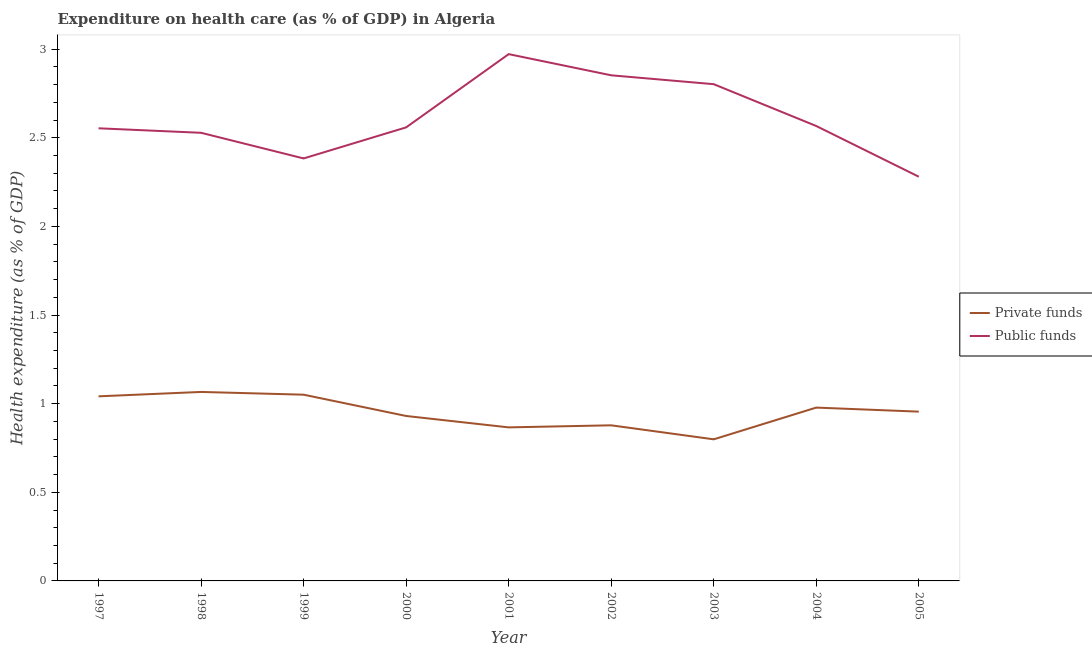Does the line corresponding to amount of private funds spent in healthcare intersect with the line corresponding to amount of public funds spent in healthcare?
Give a very brief answer. No. Is the number of lines equal to the number of legend labels?
Make the answer very short. Yes. What is the amount of private funds spent in healthcare in 2001?
Provide a short and direct response. 0.87. Across all years, what is the maximum amount of private funds spent in healthcare?
Your answer should be compact. 1.07. Across all years, what is the minimum amount of public funds spent in healthcare?
Your answer should be very brief. 2.28. What is the total amount of private funds spent in healthcare in the graph?
Keep it short and to the point. 8.56. What is the difference between the amount of private funds spent in healthcare in 2003 and that in 2005?
Your answer should be very brief. -0.16. What is the difference between the amount of private funds spent in healthcare in 1999 and the amount of public funds spent in healthcare in 2001?
Your response must be concise. -1.92. What is the average amount of public funds spent in healthcare per year?
Keep it short and to the point. 2.61. In the year 2000, what is the difference between the amount of private funds spent in healthcare and amount of public funds spent in healthcare?
Provide a succinct answer. -1.63. In how many years, is the amount of private funds spent in healthcare greater than 1.5 %?
Your response must be concise. 0. What is the ratio of the amount of public funds spent in healthcare in 2002 to that in 2005?
Your answer should be very brief. 1.25. Is the amount of public funds spent in healthcare in 2003 less than that in 2005?
Your response must be concise. No. Is the difference between the amount of private funds spent in healthcare in 2001 and 2003 greater than the difference between the amount of public funds spent in healthcare in 2001 and 2003?
Your response must be concise. No. What is the difference between the highest and the second highest amount of private funds spent in healthcare?
Provide a short and direct response. 0.02. What is the difference between the highest and the lowest amount of private funds spent in healthcare?
Your answer should be very brief. 0.27. Is the sum of the amount of private funds spent in healthcare in 2000 and 2003 greater than the maximum amount of public funds spent in healthcare across all years?
Your answer should be very brief. No. How many lines are there?
Offer a terse response. 2. What is the difference between two consecutive major ticks on the Y-axis?
Your answer should be very brief. 0.5. Does the graph contain any zero values?
Ensure brevity in your answer.  No. Does the graph contain grids?
Keep it short and to the point. No. Where does the legend appear in the graph?
Offer a very short reply. Center right. What is the title of the graph?
Offer a terse response. Expenditure on health care (as % of GDP) in Algeria. What is the label or title of the X-axis?
Provide a short and direct response. Year. What is the label or title of the Y-axis?
Keep it short and to the point. Health expenditure (as % of GDP). What is the Health expenditure (as % of GDP) of Private funds in 1997?
Offer a very short reply. 1.04. What is the Health expenditure (as % of GDP) in Public funds in 1997?
Your answer should be very brief. 2.55. What is the Health expenditure (as % of GDP) in Private funds in 1998?
Make the answer very short. 1.07. What is the Health expenditure (as % of GDP) in Public funds in 1998?
Ensure brevity in your answer.  2.53. What is the Health expenditure (as % of GDP) of Private funds in 1999?
Your answer should be very brief. 1.05. What is the Health expenditure (as % of GDP) in Public funds in 1999?
Provide a succinct answer. 2.38. What is the Health expenditure (as % of GDP) of Private funds in 2000?
Make the answer very short. 0.93. What is the Health expenditure (as % of GDP) of Public funds in 2000?
Offer a very short reply. 2.56. What is the Health expenditure (as % of GDP) of Private funds in 2001?
Your response must be concise. 0.87. What is the Health expenditure (as % of GDP) in Public funds in 2001?
Your answer should be compact. 2.97. What is the Health expenditure (as % of GDP) in Private funds in 2002?
Provide a succinct answer. 0.88. What is the Health expenditure (as % of GDP) in Public funds in 2002?
Give a very brief answer. 2.85. What is the Health expenditure (as % of GDP) of Private funds in 2003?
Offer a terse response. 0.8. What is the Health expenditure (as % of GDP) of Public funds in 2003?
Offer a terse response. 2.8. What is the Health expenditure (as % of GDP) in Private funds in 2004?
Your answer should be very brief. 0.98. What is the Health expenditure (as % of GDP) in Public funds in 2004?
Your answer should be compact. 2.57. What is the Health expenditure (as % of GDP) of Private funds in 2005?
Provide a succinct answer. 0.95. What is the Health expenditure (as % of GDP) in Public funds in 2005?
Keep it short and to the point. 2.28. Across all years, what is the maximum Health expenditure (as % of GDP) of Private funds?
Make the answer very short. 1.07. Across all years, what is the maximum Health expenditure (as % of GDP) of Public funds?
Offer a very short reply. 2.97. Across all years, what is the minimum Health expenditure (as % of GDP) in Private funds?
Provide a succinct answer. 0.8. Across all years, what is the minimum Health expenditure (as % of GDP) in Public funds?
Offer a terse response. 2.28. What is the total Health expenditure (as % of GDP) of Private funds in the graph?
Provide a succinct answer. 8.56. What is the total Health expenditure (as % of GDP) in Public funds in the graph?
Ensure brevity in your answer.  23.5. What is the difference between the Health expenditure (as % of GDP) of Private funds in 1997 and that in 1998?
Offer a terse response. -0.02. What is the difference between the Health expenditure (as % of GDP) in Public funds in 1997 and that in 1998?
Keep it short and to the point. 0.03. What is the difference between the Health expenditure (as % of GDP) in Private funds in 1997 and that in 1999?
Your response must be concise. -0.01. What is the difference between the Health expenditure (as % of GDP) in Public funds in 1997 and that in 1999?
Offer a terse response. 0.17. What is the difference between the Health expenditure (as % of GDP) of Private funds in 1997 and that in 2000?
Ensure brevity in your answer.  0.11. What is the difference between the Health expenditure (as % of GDP) of Public funds in 1997 and that in 2000?
Your response must be concise. -0.01. What is the difference between the Health expenditure (as % of GDP) in Private funds in 1997 and that in 2001?
Ensure brevity in your answer.  0.18. What is the difference between the Health expenditure (as % of GDP) of Public funds in 1997 and that in 2001?
Make the answer very short. -0.42. What is the difference between the Health expenditure (as % of GDP) in Private funds in 1997 and that in 2002?
Offer a very short reply. 0.16. What is the difference between the Health expenditure (as % of GDP) in Public funds in 1997 and that in 2002?
Ensure brevity in your answer.  -0.3. What is the difference between the Health expenditure (as % of GDP) in Private funds in 1997 and that in 2003?
Offer a terse response. 0.24. What is the difference between the Health expenditure (as % of GDP) in Public funds in 1997 and that in 2003?
Your answer should be very brief. -0.25. What is the difference between the Health expenditure (as % of GDP) in Private funds in 1997 and that in 2004?
Ensure brevity in your answer.  0.06. What is the difference between the Health expenditure (as % of GDP) in Public funds in 1997 and that in 2004?
Make the answer very short. -0.01. What is the difference between the Health expenditure (as % of GDP) of Private funds in 1997 and that in 2005?
Your answer should be compact. 0.09. What is the difference between the Health expenditure (as % of GDP) in Public funds in 1997 and that in 2005?
Offer a very short reply. 0.27. What is the difference between the Health expenditure (as % of GDP) in Private funds in 1998 and that in 1999?
Offer a terse response. 0.02. What is the difference between the Health expenditure (as % of GDP) of Public funds in 1998 and that in 1999?
Offer a very short reply. 0.14. What is the difference between the Health expenditure (as % of GDP) in Private funds in 1998 and that in 2000?
Keep it short and to the point. 0.14. What is the difference between the Health expenditure (as % of GDP) in Public funds in 1998 and that in 2000?
Your answer should be very brief. -0.03. What is the difference between the Health expenditure (as % of GDP) in Private funds in 1998 and that in 2001?
Your response must be concise. 0.2. What is the difference between the Health expenditure (as % of GDP) in Public funds in 1998 and that in 2001?
Your answer should be compact. -0.44. What is the difference between the Health expenditure (as % of GDP) in Private funds in 1998 and that in 2002?
Your response must be concise. 0.19. What is the difference between the Health expenditure (as % of GDP) in Public funds in 1998 and that in 2002?
Your answer should be very brief. -0.32. What is the difference between the Health expenditure (as % of GDP) in Private funds in 1998 and that in 2003?
Your response must be concise. 0.27. What is the difference between the Health expenditure (as % of GDP) in Public funds in 1998 and that in 2003?
Offer a terse response. -0.27. What is the difference between the Health expenditure (as % of GDP) of Private funds in 1998 and that in 2004?
Make the answer very short. 0.09. What is the difference between the Health expenditure (as % of GDP) of Public funds in 1998 and that in 2004?
Your response must be concise. -0.04. What is the difference between the Health expenditure (as % of GDP) of Private funds in 1998 and that in 2005?
Provide a succinct answer. 0.11. What is the difference between the Health expenditure (as % of GDP) in Public funds in 1998 and that in 2005?
Offer a very short reply. 0.25. What is the difference between the Health expenditure (as % of GDP) in Private funds in 1999 and that in 2000?
Your answer should be very brief. 0.12. What is the difference between the Health expenditure (as % of GDP) of Public funds in 1999 and that in 2000?
Provide a short and direct response. -0.18. What is the difference between the Health expenditure (as % of GDP) in Private funds in 1999 and that in 2001?
Offer a terse response. 0.18. What is the difference between the Health expenditure (as % of GDP) of Public funds in 1999 and that in 2001?
Your answer should be very brief. -0.59. What is the difference between the Health expenditure (as % of GDP) of Private funds in 1999 and that in 2002?
Give a very brief answer. 0.17. What is the difference between the Health expenditure (as % of GDP) of Public funds in 1999 and that in 2002?
Offer a terse response. -0.47. What is the difference between the Health expenditure (as % of GDP) in Private funds in 1999 and that in 2003?
Your answer should be compact. 0.25. What is the difference between the Health expenditure (as % of GDP) of Public funds in 1999 and that in 2003?
Make the answer very short. -0.42. What is the difference between the Health expenditure (as % of GDP) of Private funds in 1999 and that in 2004?
Provide a short and direct response. 0.07. What is the difference between the Health expenditure (as % of GDP) in Public funds in 1999 and that in 2004?
Make the answer very short. -0.18. What is the difference between the Health expenditure (as % of GDP) of Private funds in 1999 and that in 2005?
Give a very brief answer. 0.1. What is the difference between the Health expenditure (as % of GDP) in Public funds in 1999 and that in 2005?
Keep it short and to the point. 0.1. What is the difference between the Health expenditure (as % of GDP) of Private funds in 2000 and that in 2001?
Offer a terse response. 0.06. What is the difference between the Health expenditure (as % of GDP) of Public funds in 2000 and that in 2001?
Make the answer very short. -0.41. What is the difference between the Health expenditure (as % of GDP) of Private funds in 2000 and that in 2002?
Give a very brief answer. 0.05. What is the difference between the Health expenditure (as % of GDP) of Public funds in 2000 and that in 2002?
Your answer should be very brief. -0.29. What is the difference between the Health expenditure (as % of GDP) of Private funds in 2000 and that in 2003?
Give a very brief answer. 0.13. What is the difference between the Health expenditure (as % of GDP) in Public funds in 2000 and that in 2003?
Make the answer very short. -0.24. What is the difference between the Health expenditure (as % of GDP) in Private funds in 2000 and that in 2004?
Offer a terse response. -0.05. What is the difference between the Health expenditure (as % of GDP) in Public funds in 2000 and that in 2004?
Your response must be concise. -0.01. What is the difference between the Health expenditure (as % of GDP) in Private funds in 2000 and that in 2005?
Provide a succinct answer. -0.02. What is the difference between the Health expenditure (as % of GDP) in Public funds in 2000 and that in 2005?
Ensure brevity in your answer.  0.28. What is the difference between the Health expenditure (as % of GDP) in Private funds in 2001 and that in 2002?
Offer a very short reply. -0.01. What is the difference between the Health expenditure (as % of GDP) in Public funds in 2001 and that in 2002?
Make the answer very short. 0.12. What is the difference between the Health expenditure (as % of GDP) of Private funds in 2001 and that in 2003?
Offer a very short reply. 0.07. What is the difference between the Health expenditure (as % of GDP) in Public funds in 2001 and that in 2003?
Ensure brevity in your answer.  0.17. What is the difference between the Health expenditure (as % of GDP) in Private funds in 2001 and that in 2004?
Ensure brevity in your answer.  -0.11. What is the difference between the Health expenditure (as % of GDP) of Public funds in 2001 and that in 2004?
Keep it short and to the point. 0.41. What is the difference between the Health expenditure (as % of GDP) of Private funds in 2001 and that in 2005?
Your answer should be very brief. -0.09. What is the difference between the Health expenditure (as % of GDP) of Public funds in 2001 and that in 2005?
Keep it short and to the point. 0.69. What is the difference between the Health expenditure (as % of GDP) of Private funds in 2002 and that in 2003?
Provide a short and direct response. 0.08. What is the difference between the Health expenditure (as % of GDP) in Public funds in 2002 and that in 2004?
Give a very brief answer. 0.29. What is the difference between the Health expenditure (as % of GDP) in Private funds in 2002 and that in 2005?
Provide a short and direct response. -0.08. What is the difference between the Health expenditure (as % of GDP) in Public funds in 2002 and that in 2005?
Your answer should be compact. 0.57. What is the difference between the Health expenditure (as % of GDP) of Private funds in 2003 and that in 2004?
Ensure brevity in your answer.  -0.18. What is the difference between the Health expenditure (as % of GDP) of Public funds in 2003 and that in 2004?
Your response must be concise. 0.24. What is the difference between the Health expenditure (as % of GDP) in Private funds in 2003 and that in 2005?
Keep it short and to the point. -0.16. What is the difference between the Health expenditure (as % of GDP) of Public funds in 2003 and that in 2005?
Offer a terse response. 0.52. What is the difference between the Health expenditure (as % of GDP) of Private funds in 2004 and that in 2005?
Offer a very short reply. 0.02. What is the difference between the Health expenditure (as % of GDP) in Public funds in 2004 and that in 2005?
Your response must be concise. 0.29. What is the difference between the Health expenditure (as % of GDP) in Private funds in 1997 and the Health expenditure (as % of GDP) in Public funds in 1998?
Your answer should be very brief. -1.49. What is the difference between the Health expenditure (as % of GDP) in Private funds in 1997 and the Health expenditure (as % of GDP) in Public funds in 1999?
Your answer should be compact. -1.34. What is the difference between the Health expenditure (as % of GDP) of Private funds in 1997 and the Health expenditure (as % of GDP) of Public funds in 2000?
Ensure brevity in your answer.  -1.52. What is the difference between the Health expenditure (as % of GDP) of Private funds in 1997 and the Health expenditure (as % of GDP) of Public funds in 2001?
Keep it short and to the point. -1.93. What is the difference between the Health expenditure (as % of GDP) of Private funds in 1997 and the Health expenditure (as % of GDP) of Public funds in 2002?
Provide a succinct answer. -1.81. What is the difference between the Health expenditure (as % of GDP) in Private funds in 1997 and the Health expenditure (as % of GDP) in Public funds in 2003?
Provide a succinct answer. -1.76. What is the difference between the Health expenditure (as % of GDP) of Private funds in 1997 and the Health expenditure (as % of GDP) of Public funds in 2004?
Keep it short and to the point. -1.52. What is the difference between the Health expenditure (as % of GDP) of Private funds in 1997 and the Health expenditure (as % of GDP) of Public funds in 2005?
Your response must be concise. -1.24. What is the difference between the Health expenditure (as % of GDP) of Private funds in 1998 and the Health expenditure (as % of GDP) of Public funds in 1999?
Your answer should be compact. -1.32. What is the difference between the Health expenditure (as % of GDP) in Private funds in 1998 and the Health expenditure (as % of GDP) in Public funds in 2000?
Make the answer very short. -1.49. What is the difference between the Health expenditure (as % of GDP) of Private funds in 1998 and the Health expenditure (as % of GDP) of Public funds in 2001?
Ensure brevity in your answer.  -1.91. What is the difference between the Health expenditure (as % of GDP) of Private funds in 1998 and the Health expenditure (as % of GDP) of Public funds in 2002?
Keep it short and to the point. -1.79. What is the difference between the Health expenditure (as % of GDP) in Private funds in 1998 and the Health expenditure (as % of GDP) in Public funds in 2003?
Your answer should be very brief. -1.74. What is the difference between the Health expenditure (as % of GDP) in Private funds in 1998 and the Health expenditure (as % of GDP) in Public funds in 2004?
Make the answer very short. -1.5. What is the difference between the Health expenditure (as % of GDP) of Private funds in 1998 and the Health expenditure (as % of GDP) of Public funds in 2005?
Provide a succinct answer. -1.21. What is the difference between the Health expenditure (as % of GDP) of Private funds in 1999 and the Health expenditure (as % of GDP) of Public funds in 2000?
Your answer should be compact. -1.51. What is the difference between the Health expenditure (as % of GDP) of Private funds in 1999 and the Health expenditure (as % of GDP) of Public funds in 2001?
Keep it short and to the point. -1.92. What is the difference between the Health expenditure (as % of GDP) of Private funds in 1999 and the Health expenditure (as % of GDP) of Public funds in 2002?
Offer a very short reply. -1.8. What is the difference between the Health expenditure (as % of GDP) of Private funds in 1999 and the Health expenditure (as % of GDP) of Public funds in 2003?
Keep it short and to the point. -1.75. What is the difference between the Health expenditure (as % of GDP) in Private funds in 1999 and the Health expenditure (as % of GDP) in Public funds in 2004?
Keep it short and to the point. -1.52. What is the difference between the Health expenditure (as % of GDP) in Private funds in 1999 and the Health expenditure (as % of GDP) in Public funds in 2005?
Your response must be concise. -1.23. What is the difference between the Health expenditure (as % of GDP) in Private funds in 2000 and the Health expenditure (as % of GDP) in Public funds in 2001?
Make the answer very short. -2.04. What is the difference between the Health expenditure (as % of GDP) of Private funds in 2000 and the Health expenditure (as % of GDP) of Public funds in 2002?
Give a very brief answer. -1.92. What is the difference between the Health expenditure (as % of GDP) of Private funds in 2000 and the Health expenditure (as % of GDP) of Public funds in 2003?
Your response must be concise. -1.87. What is the difference between the Health expenditure (as % of GDP) in Private funds in 2000 and the Health expenditure (as % of GDP) in Public funds in 2004?
Offer a terse response. -1.64. What is the difference between the Health expenditure (as % of GDP) of Private funds in 2000 and the Health expenditure (as % of GDP) of Public funds in 2005?
Offer a very short reply. -1.35. What is the difference between the Health expenditure (as % of GDP) of Private funds in 2001 and the Health expenditure (as % of GDP) of Public funds in 2002?
Ensure brevity in your answer.  -1.99. What is the difference between the Health expenditure (as % of GDP) of Private funds in 2001 and the Health expenditure (as % of GDP) of Public funds in 2003?
Your answer should be very brief. -1.94. What is the difference between the Health expenditure (as % of GDP) in Private funds in 2001 and the Health expenditure (as % of GDP) in Public funds in 2004?
Offer a terse response. -1.7. What is the difference between the Health expenditure (as % of GDP) in Private funds in 2001 and the Health expenditure (as % of GDP) in Public funds in 2005?
Your answer should be compact. -1.41. What is the difference between the Health expenditure (as % of GDP) in Private funds in 2002 and the Health expenditure (as % of GDP) in Public funds in 2003?
Your answer should be very brief. -1.92. What is the difference between the Health expenditure (as % of GDP) in Private funds in 2002 and the Health expenditure (as % of GDP) in Public funds in 2004?
Give a very brief answer. -1.69. What is the difference between the Health expenditure (as % of GDP) in Private funds in 2002 and the Health expenditure (as % of GDP) in Public funds in 2005?
Keep it short and to the point. -1.4. What is the difference between the Health expenditure (as % of GDP) in Private funds in 2003 and the Health expenditure (as % of GDP) in Public funds in 2004?
Your answer should be compact. -1.77. What is the difference between the Health expenditure (as % of GDP) of Private funds in 2003 and the Health expenditure (as % of GDP) of Public funds in 2005?
Ensure brevity in your answer.  -1.48. What is the difference between the Health expenditure (as % of GDP) in Private funds in 2004 and the Health expenditure (as % of GDP) in Public funds in 2005?
Ensure brevity in your answer.  -1.3. What is the average Health expenditure (as % of GDP) in Private funds per year?
Provide a short and direct response. 0.95. What is the average Health expenditure (as % of GDP) of Public funds per year?
Your response must be concise. 2.61. In the year 1997, what is the difference between the Health expenditure (as % of GDP) in Private funds and Health expenditure (as % of GDP) in Public funds?
Provide a short and direct response. -1.51. In the year 1998, what is the difference between the Health expenditure (as % of GDP) in Private funds and Health expenditure (as % of GDP) in Public funds?
Ensure brevity in your answer.  -1.46. In the year 1999, what is the difference between the Health expenditure (as % of GDP) of Private funds and Health expenditure (as % of GDP) of Public funds?
Provide a short and direct response. -1.33. In the year 2000, what is the difference between the Health expenditure (as % of GDP) in Private funds and Health expenditure (as % of GDP) in Public funds?
Make the answer very short. -1.63. In the year 2001, what is the difference between the Health expenditure (as % of GDP) in Private funds and Health expenditure (as % of GDP) in Public funds?
Offer a very short reply. -2.11. In the year 2002, what is the difference between the Health expenditure (as % of GDP) of Private funds and Health expenditure (as % of GDP) of Public funds?
Give a very brief answer. -1.97. In the year 2003, what is the difference between the Health expenditure (as % of GDP) in Private funds and Health expenditure (as % of GDP) in Public funds?
Offer a terse response. -2. In the year 2004, what is the difference between the Health expenditure (as % of GDP) of Private funds and Health expenditure (as % of GDP) of Public funds?
Your answer should be very brief. -1.59. In the year 2005, what is the difference between the Health expenditure (as % of GDP) of Private funds and Health expenditure (as % of GDP) of Public funds?
Your answer should be very brief. -1.33. What is the ratio of the Health expenditure (as % of GDP) of Private funds in 1997 to that in 1998?
Make the answer very short. 0.98. What is the ratio of the Health expenditure (as % of GDP) in Public funds in 1997 to that in 1999?
Provide a succinct answer. 1.07. What is the ratio of the Health expenditure (as % of GDP) in Private funds in 1997 to that in 2000?
Make the answer very short. 1.12. What is the ratio of the Health expenditure (as % of GDP) in Public funds in 1997 to that in 2000?
Your answer should be compact. 1. What is the ratio of the Health expenditure (as % of GDP) of Private funds in 1997 to that in 2001?
Provide a succinct answer. 1.2. What is the ratio of the Health expenditure (as % of GDP) of Public funds in 1997 to that in 2001?
Provide a succinct answer. 0.86. What is the ratio of the Health expenditure (as % of GDP) in Private funds in 1997 to that in 2002?
Your answer should be compact. 1.19. What is the ratio of the Health expenditure (as % of GDP) of Public funds in 1997 to that in 2002?
Offer a very short reply. 0.9. What is the ratio of the Health expenditure (as % of GDP) of Private funds in 1997 to that in 2003?
Offer a very short reply. 1.3. What is the ratio of the Health expenditure (as % of GDP) of Public funds in 1997 to that in 2003?
Offer a very short reply. 0.91. What is the ratio of the Health expenditure (as % of GDP) of Private funds in 1997 to that in 2004?
Make the answer very short. 1.06. What is the ratio of the Health expenditure (as % of GDP) in Private funds in 1997 to that in 2005?
Your answer should be compact. 1.09. What is the ratio of the Health expenditure (as % of GDP) of Public funds in 1997 to that in 2005?
Give a very brief answer. 1.12. What is the ratio of the Health expenditure (as % of GDP) of Private funds in 1998 to that in 1999?
Ensure brevity in your answer.  1.01. What is the ratio of the Health expenditure (as % of GDP) of Public funds in 1998 to that in 1999?
Keep it short and to the point. 1.06. What is the ratio of the Health expenditure (as % of GDP) in Private funds in 1998 to that in 2000?
Give a very brief answer. 1.15. What is the ratio of the Health expenditure (as % of GDP) of Private funds in 1998 to that in 2001?
Your response must be concise. 1.23. What is the ratio of the Health expenditure (as % of GDP) of Public funds in 1998 to that in 2001?
Ensure brevity in your answer.  0.85. What is the ratio of the Health expenditure (as % of GDP) in Private funds in 1998 to that in 2002?
Offer a very short reply. 1.21. What is the ratio of the Health expenditure (as % of GDP) in Public funds in 1998 to that in 2002?
Provide a succinct answer. 0.89. What is the ratio of the Health expenditure (as % of GDP) in Private funds in 1998 to that in 2003?
Keep it short and to the point. 1.33. What is the ratio of the Health expenditure (as % of GDP) of Public funds in 1998 to that in 2003?
Your response must be concise. 0.9. What is the ratio of the Health expenditure (as % of GDP) of Private funds in 1998 to that in 2004?
Offer a very short reply. 1.09. What is the ratio of the Health expenditure (as % of GDP) in Public funds in 1998 to that in 2004?
Give a very brief answer. 0.99. What is the ratio of the Health expenditure (as % of GDP) of Private funds in 1998 to that in 2005?
Provide a short and direct response. 1.12. What is the ratio of the Health expenditure (as % of GDP) of Public funds in 1998 to that in 2005?
Make the answer very short. 1.11. What is the ratio of the Health expenditure (as % of GDP) of Private funds in 1999 to that in 2000?
Your answer should be compact. 1.13. What is the ratio of the Health expenditure (as % of GDP) of Public funds in 1999 to that in 2000?
Give a very brief answer. 0.93. What is the ratio of the Health expenditure (as % of GDP) in Private funds in 1999 to that in 2001?
Your answer should be compact. 1.21. What is the ratio of the Health expenditure (as % of GDP) of Public funds in 1999 to that in 2001?
Give a very brief answer. 0.8. What is the ratio of the Health expenditure (as % of GDP) of Private funds in 1999 to that in 2002?
Your answer should be very brief. 1.2. What is the ratio of the Health expenditure (as % of GDP) of Public funds in 1999 to that in 2002?
Ensure brevity in your answer.  0.84. What is the ratio of the Health expenditure (as % of GDP) in Private funds in 1999 to that in 2003?
Your answer should be very brief. 1.32. What is the ratio of the Health expenditure (as % of GDP) in Public funds in 1999 to that in 2003?
Your response must be concise. 0.85. What is the ratio of the Health expenditure (as % of GDP) in Private funds in 1999 to that in 2004?
Ensure brevity in your answer.  1.07. What is the ratio of the Health expenditure (as % of GDP) in Public funds in 1999 to that in 2004?
Provide a short and direct response. 0.93. What is the ratio of the Health expenditure (as % of GDP) of Private funds in 1999 to that in 2005?
Make the answer very short. 1.1. What is the ratio of the Health expenditure (as % of GDP) of Public funds in 1999 to that in 2005?
Offer a very short reply. 1.05. What is the ratio of the Health expenditure (as % of GDP) of Private funds in 2000 to that in 2001?
Offer a terse response. 1.07. What is the ratio of the Health expenditure (as % of GDP) of Public funds in 2000 to that in 2001?
Ensure brevity in your answer.  0.86. What is the ratio of the Health expenditure (as % of GDP) in Private funds in 2000 to that in 2002?
Provide a succinct answer. 1.06. What is the ratio of the Health expenditure (as % of GDP) in Public funds in 2000 to that in 2002?
Make the answer very short. 0.9. What is the ratio of the Health expenditure (as % of GDP) of Private funds in 2000 to that in 2003?
Provide a short and direct response. 1.16. What is the ratio of the Health expenditure (as % of GDP) of Public funds in 2000 to that in 2003?
Provide a short and direct response. 0.91. What is the ratio of the Health expenditure (as % of GDP) in Private funds in 2000 to that in 2004?
Provide a succinct answer. 0.95. What is the ratio of the Health expenditure (as % of GDP) of Private funds in 2000 to that in 2005?
Keep it short and to the point. 0.97. What is the ratio of the Health expenditure (as % of GDP) of Public funds in 2000 to that in 2005?
Your response must be concise. 1.12. What is the ratio of the Health expenditure (as % of GDP) of Private funds in 2001 to that in 2002?
Your response must be concise. 0.99. What is the ratio of the Health expenditure (as % of GDP) of Public funds in 2001 to that in 2002?
Give a very brief answer. 1.04. What is the ratio of the Health expenditure (as % of GDP) of Private funds in 2001 to that in 2003?
Your answer should be compact. 1.08. What is the ratio of the Health expenditure (as % of GDP) in Public funds in 2001 to that in 2003?
Ensure brevity in your answer.  1.06. What is the ratio of the Health expenditure (as % of GDP) in Private funds in 2001 to that in 2004?
Offer a terse response. 0.89. What is the ratio of the Health expenditure (as % of GDP) of Public funds in 2001 to that in 2004?
Provide a short and direct response. 1.16. What is the ratio of the Health expenditure (as % of GDP) of Private funds in 2001 to that in 2005?
Keep it short and to the point. 0.91. What is the ratio of the Health expenditure (as % of GDP) in Public funds in 2001 to that in 2005?
Your answer should be compact. 1.3. What is the ratio of the Health expenditure (as % of GDP) of Private funds in 2002 to that in 2003?
Keep it short and to the point. 1.1. What is the ratio of the Health expenditure (as % of GDP) of Public funds in 2002 to that in 2003?
Your response must be concise. 1.02. What is the ratio of the Health expenditure (as % of GDP) in Private funds in 2002 to that in 2004?
Provide a short and direct response. 0.9. What is the ratio of the Health expenditure (as % of GDP) of Public funds in 2002 to that in 2004?
Offer a terse response. 1.11. What is the ratio of the Health expenditure (as % of GDP) in Private funds in 2002 to that in 2005?
Keep it short and to the point. 0.92. What is the ratio of the Health expenditure (as % of GDP) of Public funds in 2002 to that in 2005?
Your answer should be very brief. 1.25. What is the ratio of the Health expenditure (as % of GDP) of Private funds in 2003 to that in 2004?
Provide a short and direct response. 0.82. What is the ratio of the Health expenditure (as % of GDP) in Public funds in 2003 to that in 2004?
Your answer should be compact. 1.09. What is the ratio of the Health expenditure (as % of GDP) in Private funds in 2003 to that in 2005?
Keep it short and to the point. 0.84. What is the ratio of the Health expenditure (as % of GDP) in Public funds in 2003 to that in 2005?
Keep it short and to the point. 1.23. What is the ratio of the Health expenditure (as % of GDP) in Private funds in 2004 to that in 2005?
Your response must be concise. 1.02. What is the ratio of the Health expenditure (as % of GDP) of Public funds in 2004 to that in 2005?
Offer a terse response. 1.13. What is the difference between the highest and the second highest Health expenditure (as % of GDP) of Private funds?
Your answer should be very brief. 0.02. What is the difference between the highest and the second highest Health expenditure (as % of GDP) of Public funds?
Offer a terse response. 0.12. What is the difference between the highest and the lowest Health expenditure (as % of GDP) of Private funds?
Give a very brief answer. 0.27. What is the difference between the highest and the lowest Health expenditure (as % of GDP) in Public funds?
Your answer should be very brief. 0.69. 